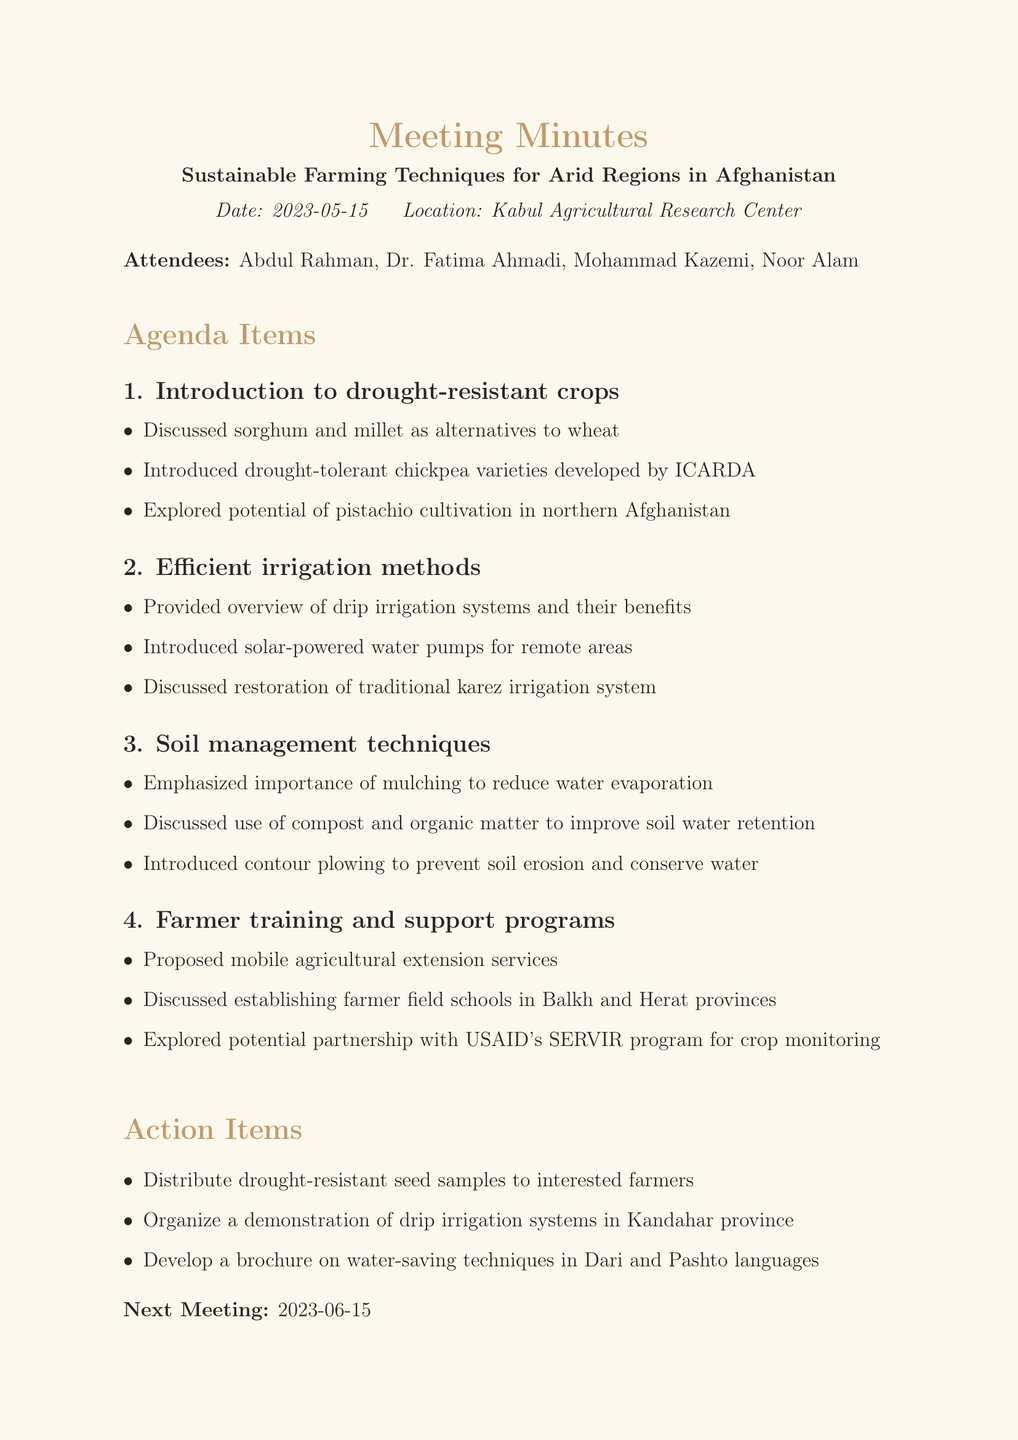What is the date of the meeting? The date of the meeting is provided at the beginning of the document.
Answer: 2023-05-15 Who introduced the drought-tolerant chickpea varieties? The document attributes the introduction of chickpea varieties to ICARDA as mentioned in the discussion points.
Answer: ICARDA What irrigation method involves solar-powered water pumps? This method is specifically mentioned under the efficient irrigation methods section of the agenda.
Answer: Solar-powered water pumps Which technique is emphasized to reduce water evaporation? The soil management techniques section discusses methods for improving soil water retention, including this specific technique.
Answer: Mulching What is the proposed service for farmer training? The agenda discusses farmer training and support programs and proposes a specific service for assistance.
Answer: Mobile agricultural extension services What crop alternatives were discussed? The document notes discussions about alternatives to wheat and lists specific crops that were considered.
Answer: Sorghum and millet What is the location of the next meeting? The next meeting information is listed at the end of the document.
Answer: Not specified in the document Which organization is mentioned for potential crop monitoring partnership? The document discusses a potential partnership with a specific organization related to crop monitoring in the training programs section.
Answer: USAID's SERVIR program 